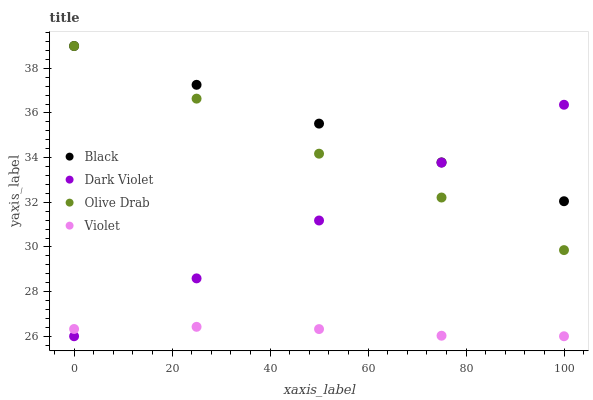Does Violet have the minimum area under the curve?
Answer yes or no. Yes. Does Black have the maximum area under the curve?
Answer yes or no. Yes. Does Olive Drab have the minimum area under the curve?
Answer yes or no. No. Does Olive Drab have the maximum area under the curve?
Answer yes or no. No. Is Dark Violet the smoothest?
Answer yes or no. Yes. Is Olive Drab the roughest?
Answer yes or no. Yes. Is Olive Drab the smoothest?
Answer yes or no. No. Is Dark Violet the roughest?
Answer yes or no. No. Does Dark Violet have the lowest value?
Answer yes or no. Yes. Does Olive Drab have the lowest value?
Answer yes or no. No. Does Olive Drab have the highest value?
Answer yes or no. Yes. Does Dark Violet have the highest value?
Answer yes or no. No. Is Violet less than Olive Drab?
Answer yes or no. Yes. Is Black greater than Violet?
Answer yes or no. Yes. Does Olive Drab intersect Black?
Answer yes or no. Yes. Is Olive Drab less than Black?
Answer yes or no. No. Is Olive Drab greater than Black?
Answer yes or no. No. Does Violet intersect Olive Drab?
Answer yes or no. No. 